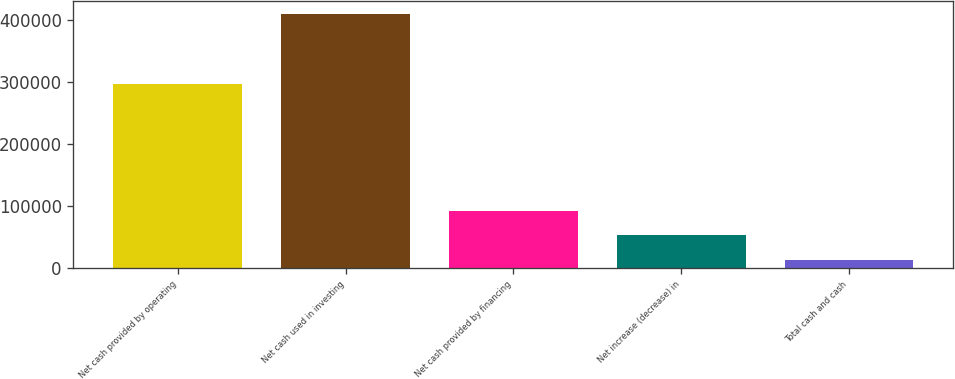Convert chart. <chart><loc_0><loc_0><loc_500><loc_500><bar_chart><fcel>Net cash provided by operating<fcel>Net cash used in investing<fcel>Net cash provided by financing<fcel>Net increase (decrease) in<fcel>Total cash and cash<nl><fcel>297360<fcel>409671<fcel>92539<fcel>52897.5<fcel>13256<nl></chart> 